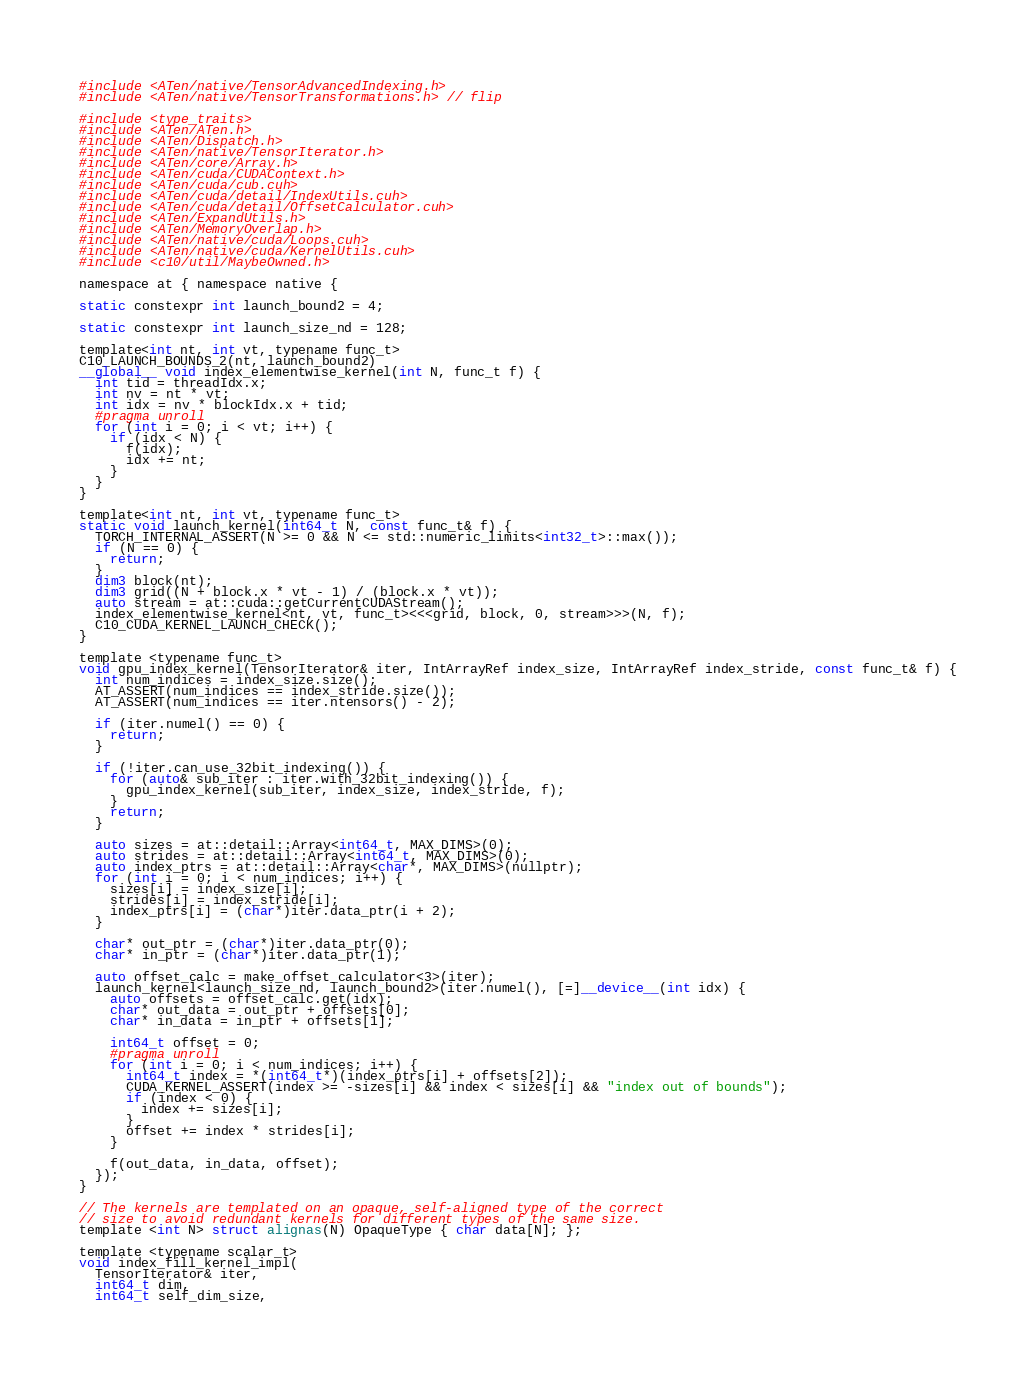<code> <loc_0><loc_0><loc_500><loc_500><_Cuda_>#include <ATen/native/TensorAdvancedIndexing.h>
#include <ATen/native/TensorTransformations.h> // flip

#include <type_traits>
#include <ATen/ATen.h>
#include <ATen/Dispatch.h>
#include <ATen/native/TensorIterator.h>
#include <ATen/core/Array.h>
#include <ATen/cuda/CUDAContext.h>
#include <ATen/cuda/cub.cuh>
#include <ATen/cuda/detail/IndexUtils.cuh>
#include <ATen/cuda/detail/OffsetCalculator.cuh>
#include <ATen/ExpandUtils.h>
#include <ATen/MemoryOverlap.h>
#include <ATen/native/cuda/Loops.cuh>
#include <ATen/native/cuda/KernelUtils.cuh>
#include <c10/util/MaybeOwned.h>

namespace at { namespace native {

static constexpr int launch_bound2 = 4;

static constexpr int launch_size_nd = 128;

template<int nt, int vt, typename func_t>
C10_LAUNCH_BOUNDS_2(nt, launch_bound2)
__global__ void index_elementwise_kernel(int N, func_t f) {
  int tid = threadIdx.x;
  int nv = nt * vt;
  int idx = nv * blockIdx.x + tid;
  #pragma unroll
  for (int i = 0; i < vt; i++) {
    if (idx < N) {
      f(idx);
      idx += nt;
    }
  }
}

template<int nt, int vt, typename func_t>
static void launch_kernel(int64_t N, const func_t& f) {
  TORCH_INTERNAL_ASSERT(N >= 0 && N <= std::numeric_limits<int32_t>::max());
  if (N == 0) {
    return;
  }
  dim3 block(nt);
  dim3 grid((N + block.x * vt - 1) / (block.x * vt));
  auto stream = at::cuda::getCurrentCUDAStream();
  index_elementwise_kernel<nt, vt, func_t><<<grid, block, 0, stream>>>(N, f);
  C10_CUDA_KERNEL_LAUNCH_CHECK();
}

template <typename func_t>
void gpu_index_kernel(TensorIterator& iter, IntArrayRef index_size, IntArrayRef index_stride, const func_t& f) {
  int num_indices = index_size.size();
  AT_ASSERT(num_indices == index_stride.size());
  AT_ASSERT(num_indices == iter.ntensors() - 2);

  if (iter.numel() == 0) {
    return;
  }

  if (!iter.can_use_32bit_indexing()) {
    for (auto& sub_iter : iter.with_32bit_indexing()) {
      gpu_index_kernel(sub_iter, index_size, index_stride, f);
    }
    return;
  }

  auto sizes = at::detail::Array<int64_t, MAX_DIMS>(0);
  auto strides = at::detail::Array<int64_t, MAX_DIMS>(0);
  auto index_ptrs = at::detail::Array<char*, MAX_DIMS>(nullptr);
  for (int i = 0; i < num_indices; i++) {
    sizes[i] = index_size[i];
    strides[i] = index_stride[i];
    index_ptrs[i] = (char*)iter.data_ptr(i + 2);
  }

  char* out_ptr = (char*)iter.data_ptr(0);
  char* in_ptr = (char*)iter.data_ptr(1);

  auto offset_calc = make_offset_calculator<3>(iter);
  launch_kernel<launch_size_nd, launch_bound2>(iter.numel(), [=]__device__(int idx) {
    auto offsets = offset_calc.get(idx);
    char* out_data = out_ptr + offsets[0];
    char* in_data = in_ptr + offsets[1];

    int64_t offset = 0;
    #pragma unroll
    for (int i = 0; i < num_indices; i++) {
      int64_t index = *(int64_t*)(index_ptrs[i] + offsets[2]);
      CUDA_KERNEL_ASSERT(index >= -sizes[i] && index < sizes[i] && "index out of bounds");
      if (index < 0) {
        index += sizes[i];
      }
      offset += index * strides[i];
    }

    f(out_data, in_data, offset);
  });
}

// The kernels are templated on an opaque, self-aligned type of the correct
// size to avoid redundant kernels for different types of the same size.
template <int N> struct alignas(N) OpaqueType { char data[N]; };

template <typename scalar_t>
void index_fill_kernel_impl(
  TensorIterator& iter,
  int64_t dim,
  int64_t self_dim_size,</code> 